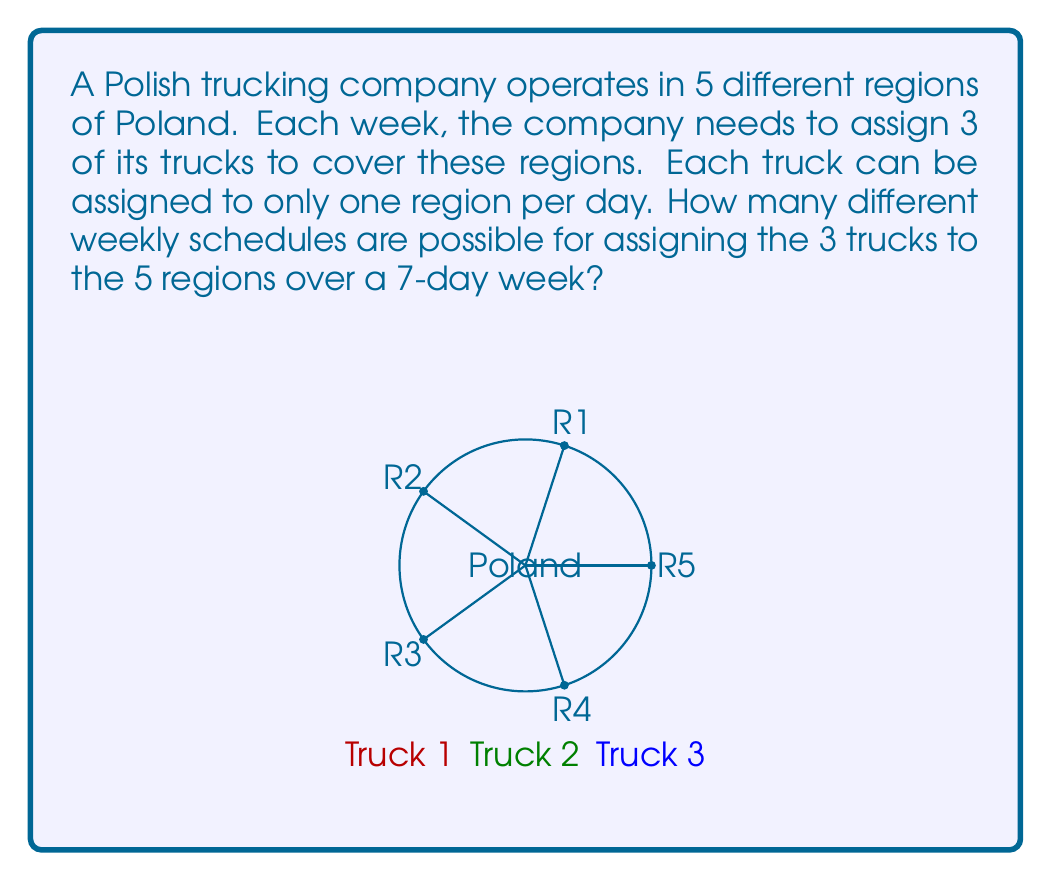Help me with this question. Let's approach this step-by-step:

1) For each day, we need to assign 3 trucks to 5 possible regions.

2) This is equivalent to choosing 3 items from 5 with replacement and where order matters. This is because:
   - A truck can be assigned to any region, even if another truck is already there (replacement).
   - The specific assignment of trucks to regions matters (order matters).

3) For each day, the number of possible assignments is:
   $5^3 = 125$
   This is because each truck has 5 choices, and we're making 3 independent choices.

4) We need to make this choice for each of the 7 days of the week.

5) Since the choices for each day are independent, we multiply the number of possibilities for each day:
   $(5^3)^7 = 125^7$

6) Calculating this:
   $125^7 = 6103515625 \times 10^9$

Therefore, there are $6103515625 \times 10^9$ different possible weekly schedules.
Answer: $6103515625 \times 10^9$ 